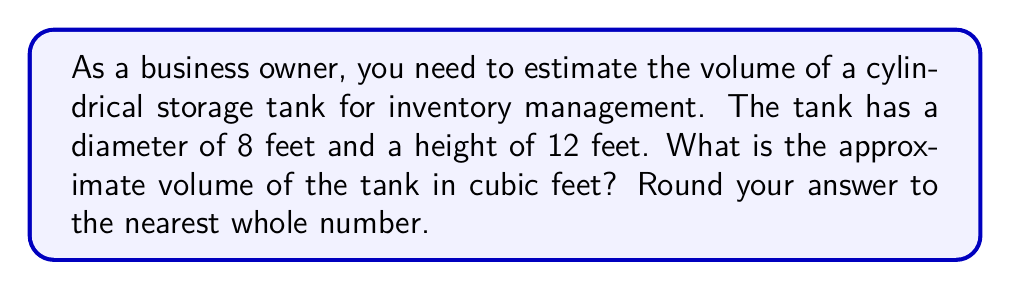Show me your answer to this math problem. To estimate the volume of a cylindrical storage tank, we need to use the formula for the volume of a cylinder:

$$V = \pi r^2 h$$

Where:
$V$ = volume
$r$ = radius of the base
$h$ = height of the cylinder

Let's solve this step-by-step:

1. Identify the given dimensions:
   - Diameter = 8 feet
   - Height = 12 feet

2. Calculate the radius:
   $r = \frac{\text{diameter}}{2} = \frac{8}{2} = 4$ feet

3. Substitute the values into the formula:
   $$V = \pi (4\text{ ft})^2 (12\text{ ft})$$

4. Calculate:
   $$V = \pi (16\text{ ft}^2) (12\text{ ft})$$
   $$V = 16\pi (12\text{ ft}^3)$$
   $$V = 192\pi \text{ ft}^3$$

5. Use 3.14 as an approximation for $\pi$:
   $$V \approx 192 \times 3.14 \text{ ft}^3$$
   $$V \approx 602.88 \text{ ft}^3$$

6. Round to the nearest whole number:
   $$V \approx 603 \text{ ft}^3$$

This estimation provides a practical volume measurement for inventory management purposes.
Answer: 603 cubic feet 